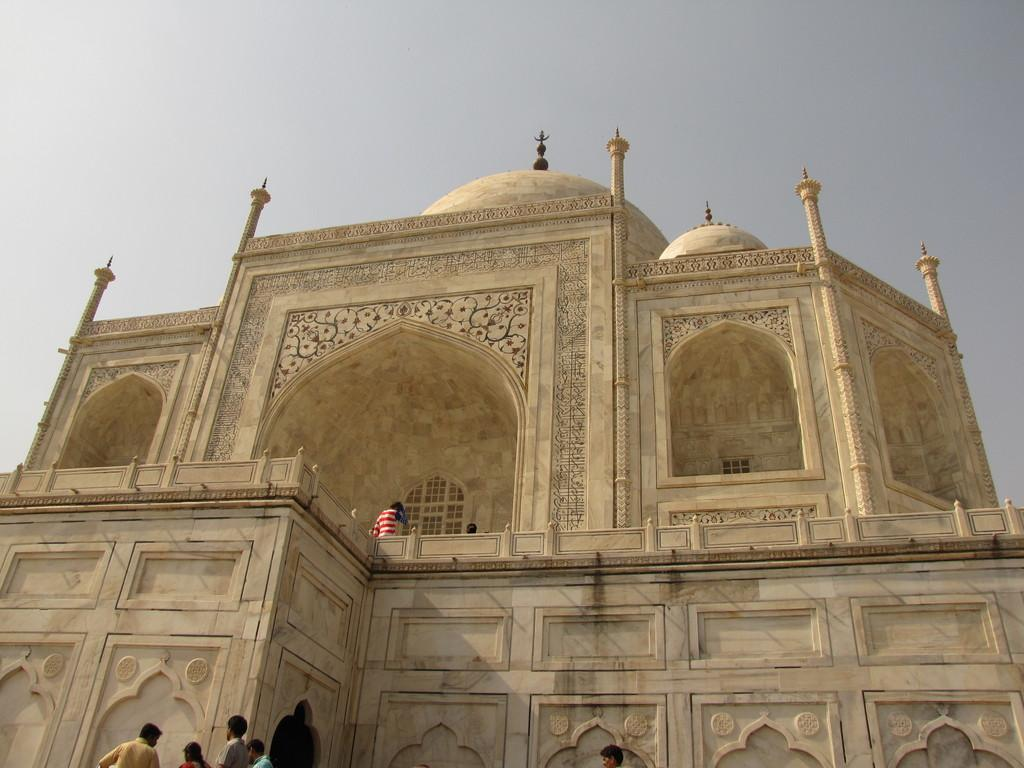What type of structure is present in the image? There is a building in the image. What feature can be seen on the building? The building has windows. Who or what else is present in the image? There is a group of people in the image. What can be seen in the background of the image? The sky is visible in the background of the image. How many fans are visible in the image? There are no fans present in the image. What type of yak can be seen grazing in the background of the image? There is no yak present in the image; the background features the sky. 